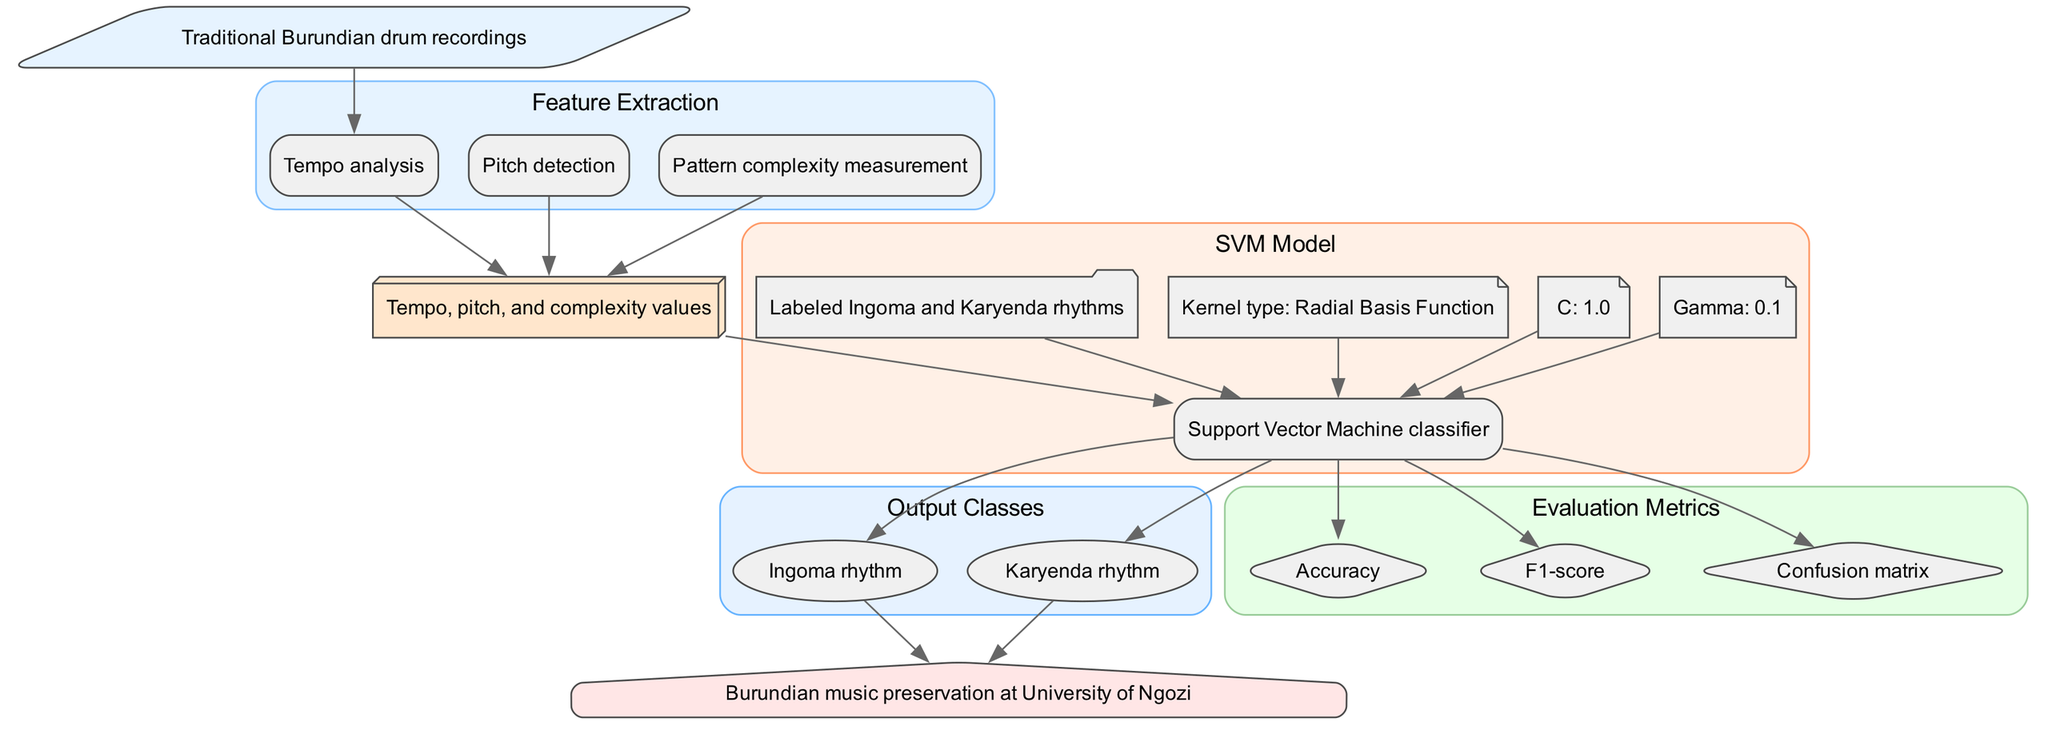What type of input data is used in this model? The diagram specifies that the input data consists of traditional Burundian drum recordings. This is indicated at the initial node labeled 'input'.
Answer: Traditional Burundian drum recordings How many features are extracted in the diagram? The diagram lists three features under the 'Feature Extraction' section, which includes tempo analysis, pitch detection, and pattern complexity measurement.
Answer: Three What is the SVM model used for? The diagram indicates that the SVM model is a Support Vector Machine classifier, specifically mentioned in the 'SVM Model' section of the diagram.
Answer: Support Vector Machine classifier What evaluation metrics are considered in this diagram? The diagram shows three evaluation metrics, namely accuracy, F1-score, and confusion matrix, listed in the 'Evaluation Metrics' section.
Answer: Accuracy, F1-score, confusion matrix What are the output classes for the SVM model? The diagram presents two output classes, which are identified as Ingoma rhythm and Karyenda rhythm in the 'Output Classes' section.
Answer: Ingoma rhythm, Karyenda rhythm What kernel type is specified for the SVM model? The diagram clearly states that the kernel type used for the SVM model is Radial Basis Function, listed under the hyperparameters in the 'SVM Model' section.
Answer: Radial Basis Function Which application is mentioned for this model? At the bottom of the diagram, the application of the model is described as Burundian music preservation at University of Ngozi, summarizing the main goal of the project.
Answer: Burundian music preservation at University of Ngozi How many hyperparameters are defined in the diagram? The diagram lists three hyperparameters associated with the SVM model, including C, gamma, and kernel type, indicating their specific values.
Answer: Three What connection exists between the feature vector and the SVM model? In the diagram, the feature vector node connects directly to the SVM model node, demonstrating that the feature vector serves as input to the SVM model.
Answer: Direct connection 